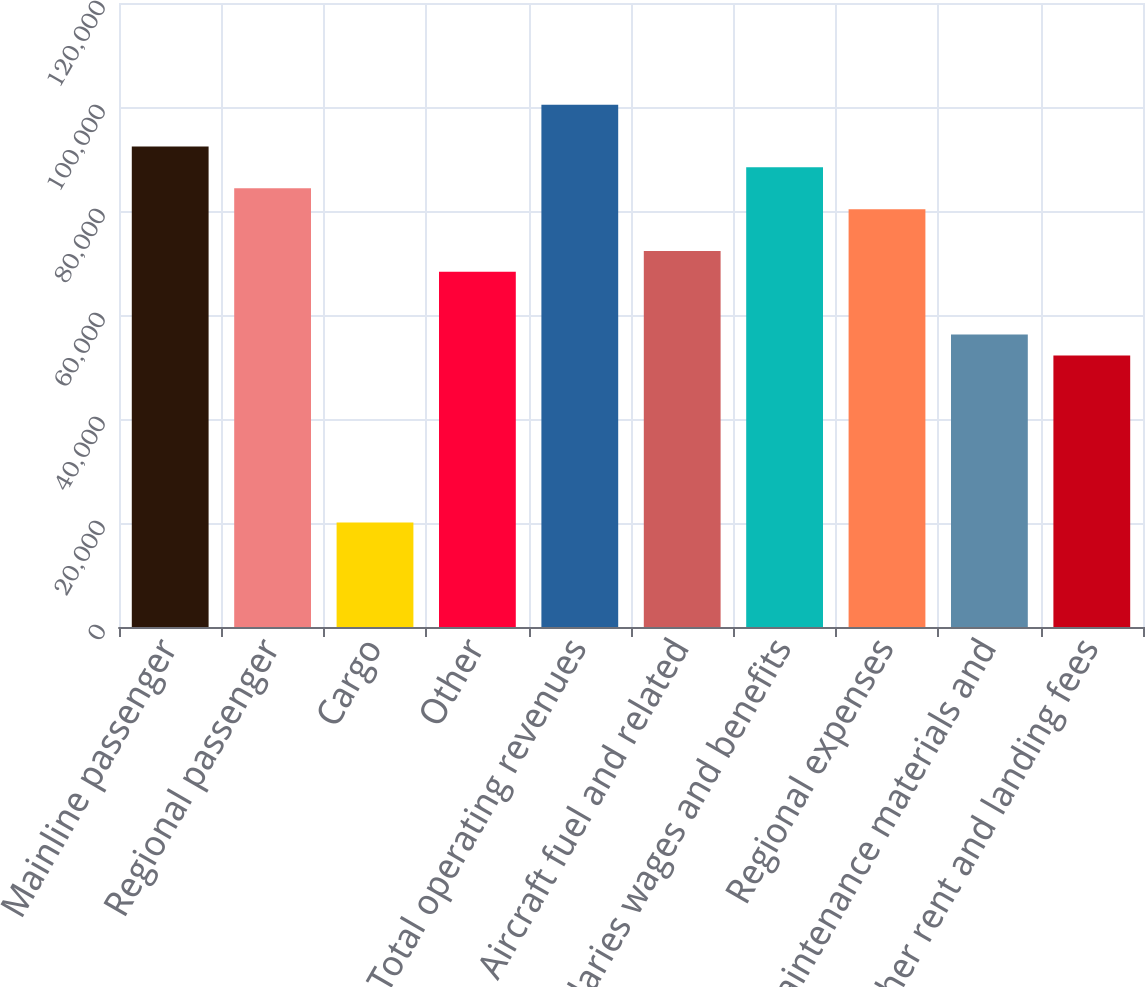Convert chart to OTSL. <chart><loc_0><loc_0><loc_500><loc_500><bar_chart><fcel>Mainline passenger<fcel>Regional passenger<fcel>Cargo<fcel>Other<fcel>Total operating revenues<fcel>Aircraft fuel and related<fcel>Salaries wages and benefits<fcel>Regional expenses<fcel>Maintenance materials and<fcel>Other rent and landing fees<nl><fcel>92413.5<fcel>84377.6<fcel>20090.2<fcel>68305.7<fcel>100449<fcel>72323.7<fcel>88395.5<fcel>80359.6<fcel>56251.8<fcel>52233.9<nl></chart> 